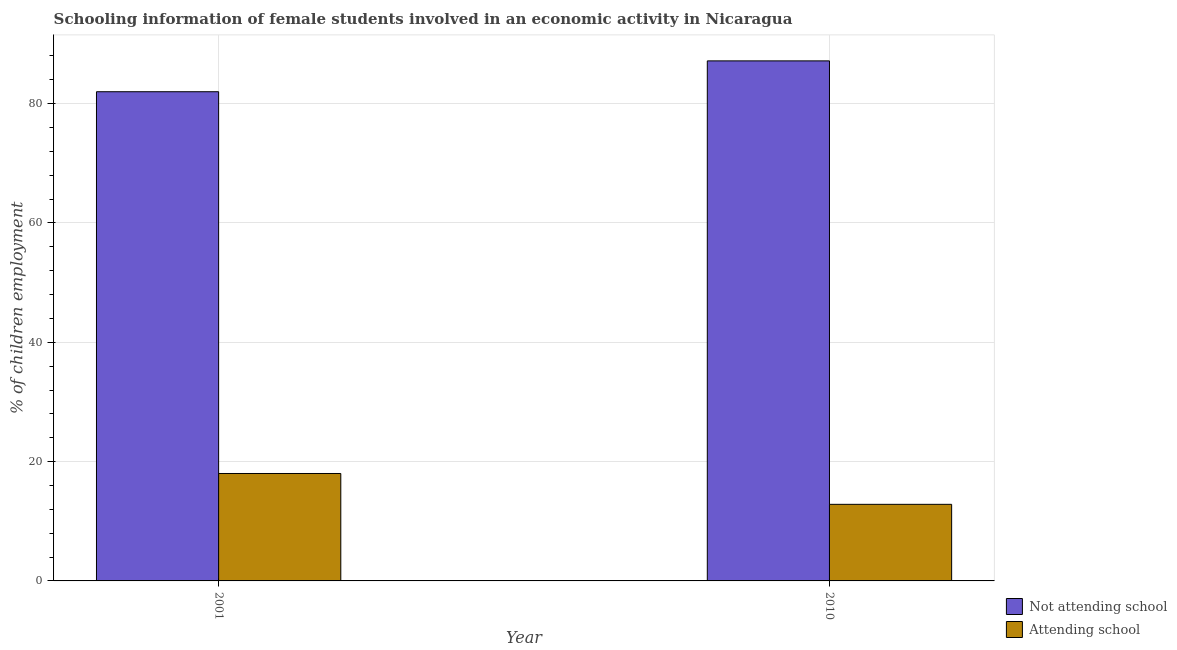How many different coloured bars are there?
Provide a succinct answer. 2. Are the number of bars on each tick of the X-axis equal?
Offer a very short reply. Yes. How many bars are there on the 2nd tick from the right?
Your answer should be very brief. 2. What is the label of the 1st group of bars from the left?
Keep it short and to the point. 2001. What is the percentage of employed females who are not attending school in 2001?
Your answer should be compact. 81.99. Across all years, what is the maximum percentage of employed females who are not attending school?
Offer a very short reply. 87.16. Across all years, what is the minimum percentage of employed females who are not attending school?
Offer a very short reply. 81.99. In which year was the percentage of employed females who are attending school minimum?
Ensure brevity in your answer.  2010. What is the total percentage of employed females who are not attending school in the graph?
Your response must be concise. 169.16. What is the difference between the percentage of employed females who are not attending school in 2001 and that in 2010?
Your answer should be very brief. -5.17. What is the difference between the percentage of employed females who are attending school in 2001 and the percentage of employed females who are not attending school in 2010?
Offer a very short reply. 5.17. What is the average percentage of employed females who are attending school per year?
Provide a succinct answer. 15.42. In how many years, is the percentage of employed females who are not attending school greater than 8 %?
Offer a terse response. 2. What is the ratio of the percentage of employed females who are not attending school in 2001 to that in 2010?
Give a very brief answer. 0.94. Is the percentage of employed females who are attending school in 2001 less than that in 2010?
Your answer should be compact. No. In how many years, is the percentage of employed females who are attending school greater than the average percentage of employed females who are attending school taken over all years?
Keep it short and to the point. 1. What does the 2nd bar from the left in 2001 represents?
Offer a very short reply. Attending school. What does the 1st bar from the right in 2001 represents?
Your response must be concise. Attending school. Are all the bars in the graph horizontal?
Ensure brevity in your answer.  No. What is the difference between two consecutive major ticks on the Y-axis?
Provide a succinct answer. 20. Does the graph contain any zero values?
Your answer should be compact. No. Does the graph contain grids?
Offer a very short reply. Yes. Where does the legend appear in the graph?
Your response must be concise. Bottom right. What is the title of the graph?
Offer a terse response. Schooling information of female students involved in an economic activity in Nicaragua. What is the label or title of the Y-axis?
Your response must be concise. % of children employment. What is the % of children employment in Not attending school in 2001?
Give a very brief answer. 81.99. What is the % of children employment of Attending school in 2001?
Give a very brief answer. 18.01. What is the % of children employment of Not attending school in 2010?
Your answer should be very brief. 87.16. What is the % of children employment of Attending school in 2010?
Your answer should be compact. 12.84. Across all years, what is the maximum % of children employment in Not attending school?
Give a very brief answer. 87.16. Across all years, what is the maximum % of children employment in Attending school?
Provide a short and direct response. 18.01. Across all years, what is the minimum % of children employment of Not attending school?
Provide a succinct answer. 81.99. Across all years, what is the minimum % of children employment of Attending school?
Offer a very short reply. 12.84. What is the total % of children employment of Not attending school in the graph?
Your response must be concise. 169.16. What is the total % of children employment of Attending school in the graph?
Make the answer very short. 30.84. What is the difference between the % of children employment in Not attending school in 2001 and that in 2010?
Give a very brief answer. -5.17. What is the difference between the % of children employment of Attending school in 2001 and that in 2010?
Your answer should be very brief. 5.17. What is the difference between the % of children employment in Not attending school in 2001 and the % of children employment in Attending school in 2010?
Make the answer very short. 69.16. What is the average % of children employment of Not attending school per year?
Your answer should be compact. 84.58. What is the average % of children employment of Attending school per year?
Provide a succinct answer. 15.42. In the year 2001, what is the difference between the % of children employment in Not attending school and % of children employment in Attending school?
Give a very brief answer. 63.99. In the year 2010, what is the difference between the % of children employment of Not attending school and % of children employment of Attending school?
Make the answer very short. 74.33. What is the ratio of the % of children employment of Not attending school in 2001 to that in 2010?
Your answer should be very brief. 0.94. What is the ratio of the % of children employment of Attending school in 2001 to that in 2010?
Give a very brief answer. 1.4. What is the difference between the highest and the second highest % of children employment in Not attending school?
Keep it short and to the point. 5.17. What is the difference between the highest and the second highest % of children employment of Attending school?
Keep it short and to the point. 5.17. What is the difference between the highest and the lowest % of children employment in Not attending school?
Your answer should be very brief. 5.17. What is the difference between the highest and the lowest % of children employment of Attending school?
Provide a short and direct response. 5.17. 